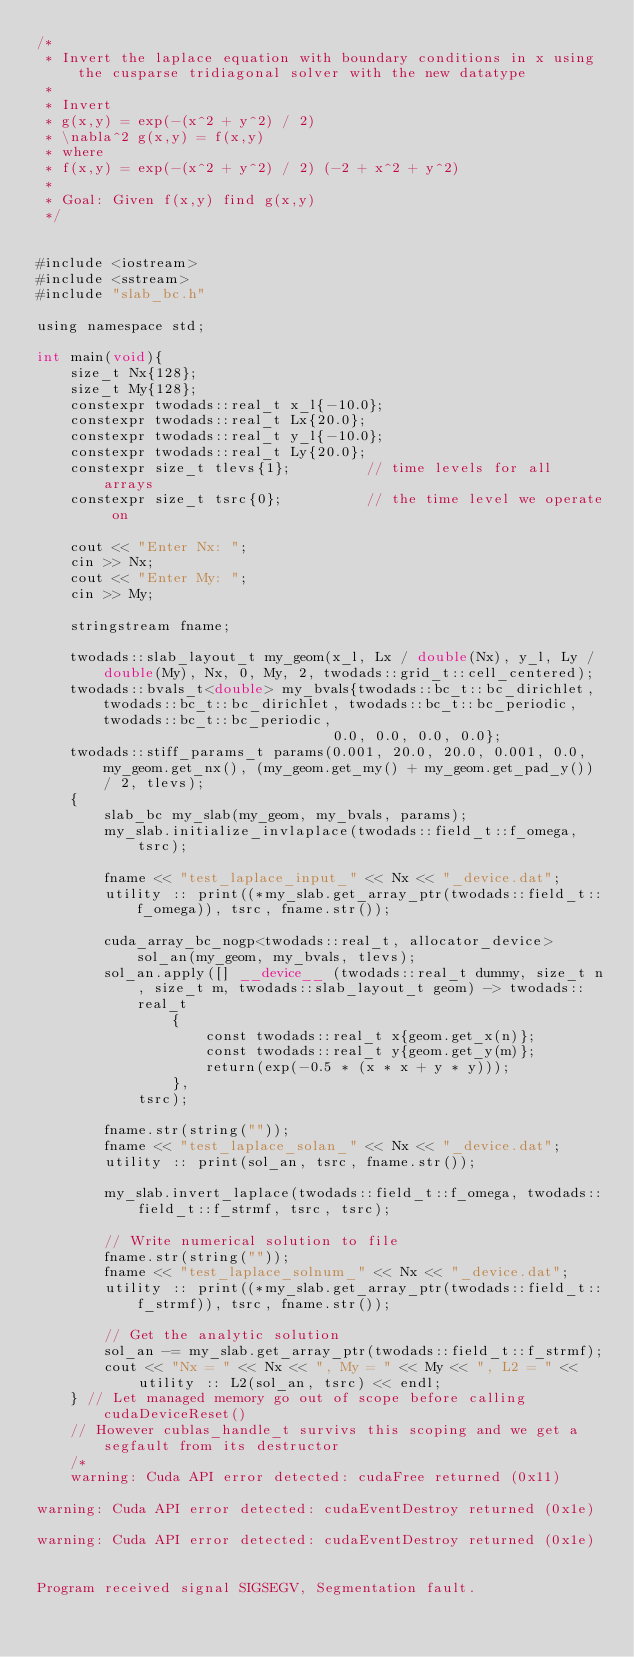Convert code to text. <code><loc_0><loc_0><loc_500><loc_500><_Cuda_>/*
 * Invert the laplace equation with boundary conditions in x using the cusparse tridiagonal solver with the new datatype
 *
 * Invert
 * g(x,y) = exp(-(x^2 + y^2) / 2)
 * \nabla^2 g(x,y) = f(x,y) 
 * where
 * f(x,y) = exp(-(x^2 + y^2) / 2) (-2 + x^2 + y^2)
 *
 * Goal: Given f(x,y) find g(x,y)
 */


#include <iostream>
#include <sstream>
#include "slab_bc.h"

using namespace std;

int main(void){
    size_t Nx{128};
    size_t My{128};
    constexpr twodads::real_t x_l{-10.0};
    constexpr twodads::real_t Lx{20.0};
    constexpr twodads::real_t y_l{-10.0};
    constexpr twodads::real_t Ly{20.0};
    constexpr size_t tlevs{1};         // time levels for all arrays
    constexpr size_t tsrc{0};          // the time level we operate on

    cout << "Enter Nx: ";
    cin >> Nx;
    cout << "Enter My: ";
    cin >> My;

    stringstream fname;

    twodads::slab_layout_t my_geom(x_l, Lx / double(Nx), y_l, Ly / double(My), Nx, 0, My, 2, twodads::grid_t::cell_centered);
    twodads::bvals_t<double> my_bvals{twodads::bc_t::bc_dirichlet, twodads::bc_t::bc_dirichlet, twodads::bc_t::bc_periodic, twodads::bc_t::bc_periodic,
                                   0.0, 0.0, 0.0, 0.0};
    twodads::stiff_params_t params(0.001, 20.0, 20.0, 0.001, 0.0, my_geom.get_nx(), (my_geom.get_my() + my_geom.get_pad_y()) / 2, tlevs);
    {
        slab_bc my_slab(my_geom, my_bvals, params);
        my_slab.initialize_invlaplace(twodads::field_t::f_omega, tsrc);

        fname << "test_laplace_input_" << Nx << "_device.dat";
        utility :: print((*my_slab.get_array_ptr(twodads::field_t::f_omega)), tsrc, fname.str());

        cuda_array_bc_nogp<twodads::real_t, allocator_device> sol_an(my_geom, my_bvals, tlevs);
        sol_an.apply([] __device__ (twodads::real_t dummy, size_t n, size_t m, twodads::slab_layout_t geom) -> twodads::real_t
                {
                    const twodads::real_t x{geom.get_x(n)};
                    const twodads::real_t y{geom.get_y(m)};
                    return(exp(-0.5 * (x * x + y * y)));
                },
            tsrc);

        fname.str(string(""));
        fname << "test_laplace_solan_" << Nx << "_device.dat";
        utility :: print(sol_an, tsrc, fname.str());

        my_slab.invert_laplace(twodads::field_t::f_omega, twodads::field_t::f_strmf, tsrc, tsrc);

        // Write numerical solution to file
        fname.str(string(""));
        fname << "test_laplace_solnum_" << Nx << "_device.dat";
        utility :: print((*my_slab.get_array_ptr(twodads::field_t::f_strmf)), tsrc, fname.str());

        // Get the analytic solution
        sol_an -= my_slab.get_array_ptr(twodads::field_t::f_strmf);
        cout << "Nx = " << Nx << ", My = " << My << ", L2 = " << utility :: L2(sol_an, tsrc) << endl;
    } // Let managed memory go out of scope before calling cudaDeviceReset()
    // However cublas_handle_t survivs this scoping and we get a segfault from its destructor
    /*
    warning: Cuda API error detected: cudaFree returned (0x11)

warning: Cuda API error detected: cudaEventDestroy returned (0x1e)

warning: Cuda API error detected: cudaEventDestroy returned (0x1e)


Program received signal SIGSEGV, Segmentation fault.</code> 